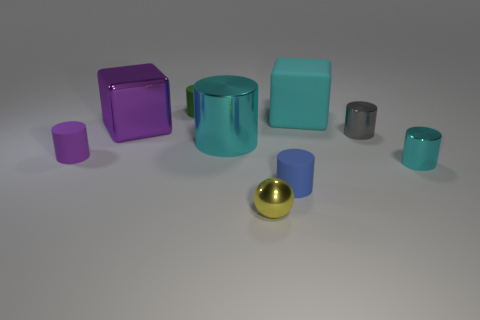How many cyan things are left of the small blue matte object and on the right side of the tiny sphere?
Make the answer very short. 0. Are there any matte objects in front of the big purple metal thing?
Your answer should be very brief. Yes. Is the shape of the gray shiny object right of the large purple metal thing the same as the purple object on the right side of the small purple cylinder?
Your response must be concise. No. What number of objects are either cyan rubber things or cyan shiny cylinders that are on the left side of the yellow shiny ball?
Offer a very short reply. 2. How many other things are there of the same shape as the blue object?
Your answer should be compact. 5. Does the small blue object in front of the green cylinder have the same material as the cyan cube?
Provide a short and direct response. Yes. What number of objects are either big purple blocks or large brown matte objects?
Your response must be concise. 1. There is a purple rubber object that is the same shape as the blue matte thing; what size is it?
Make the answer very short. Small. What size is the yellow metal sphere?
Your response must be concise. Small. Are there more metal objects left of the green cylinder than small green objects?
Offer a very short reply. No. 